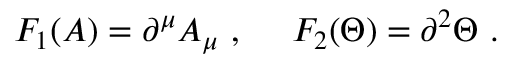Convert formula to latex. <formula><loc_0><loc_0><loc_500><loc_500>F _ { 1 } ( A ) = \partial ^ { \mu } A _ { \mu } , F _ { 2 } ( \Theta ) = \partial ^ { 2 } \Theta .</formula> 